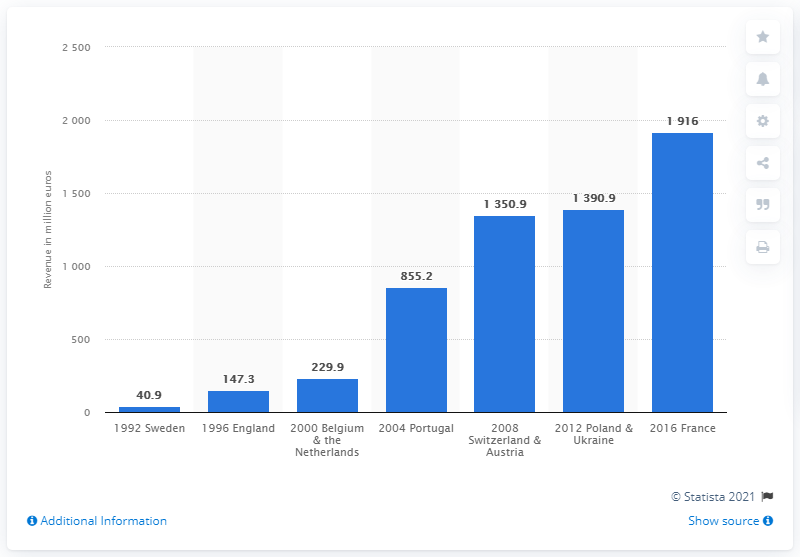Draw attention to some important aspects in this diagram. The revenue generated from the EURO 2008 was 1,350.9 million euros. 